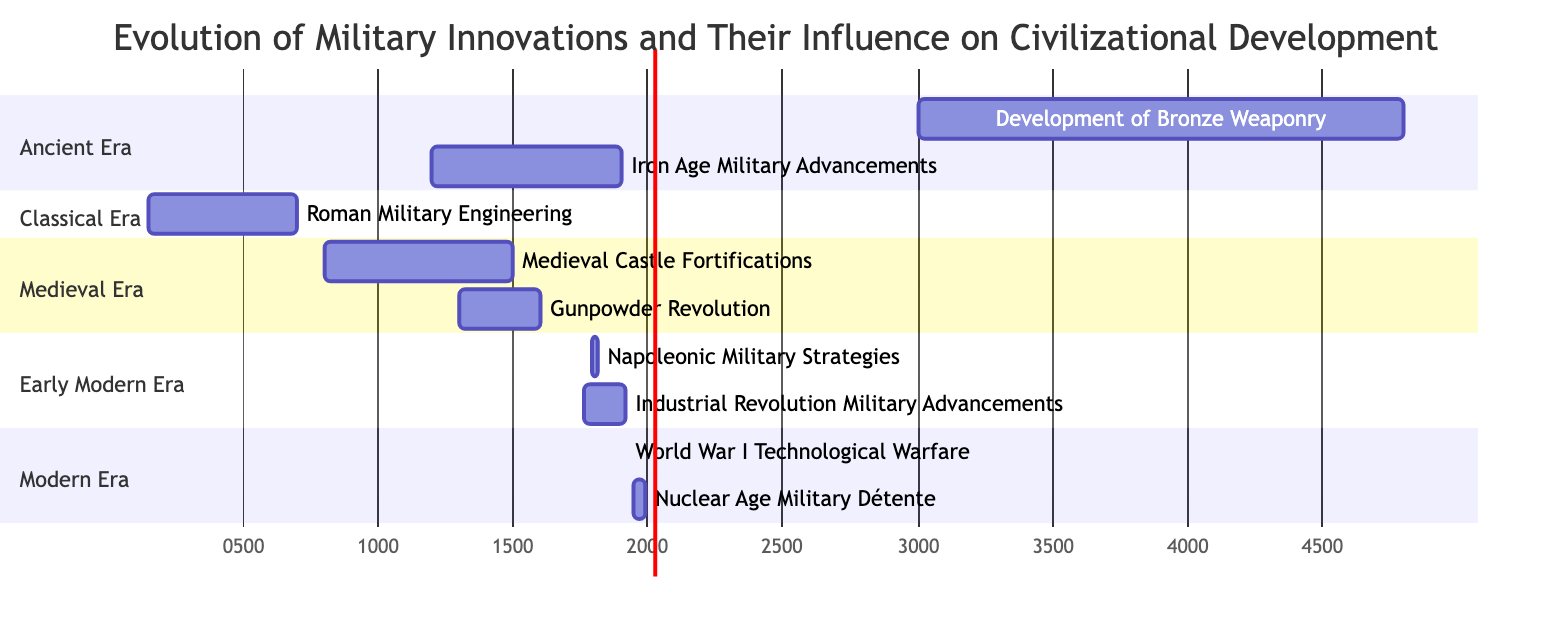What is the duration of the Gunpowder Revolution? The Gantt Chart shows that the Gunpowder Revolution starts in 1300 CE and ends in 1600 CE. To find the duration, subtract the start time from the end time: 1600 - 1300 = 300 years.
Answer: 300 years Which military innovation overlaps with the Medieval Castle Fortifications? By examining the timeline in the Gantt Chart, the Medieval Castle Fortifications begin in 800 CE and end in 1500 CE. Overlapping with it is the Gunpowder Revolution, which starts in 1300 CE and ends in 1600 CE. Thus, both innovations overlap in this period.
Answer: Gunpowder Revolution How many military innovations occurred in the Ancient Era? The Ancient Era includes two innovations according to the Gantt Chart: Development of Bronze Weaponry and Iron Age Military Advancements. Counting these innovations gives us a total of two.
Answer: 2 What time period does the Napoleonic Military Strategies cover? The Gantt Chart indicates that Napoleonic Military Strategies began in 1790 CE and ended in 1815 CE, making it a 25-year period.
Answer: 25 years Which military advancement started earliest? Looking at the start times of each innovation in the Gantt Chart, the earliest innovation is the Development of Bronze Weaponry, which begins at 3000 BCE.
Answer: Development of Bronze Weaponry What is the end year of the Industrial Revolution Military Advancements? The Gantt Chart highlights that the Industrial Revolution Military Advancements started in 1760 CE and ended in 1914 CE. Therefore, the end year for this innovation is 1914 CE.
Answer: 1914 CE Which two periods are represented in the section of the Modern Era? The Gantt Chart shows the Modern Era includes World War I Technological Warfare and Nuclear Age Military Détente. The question requires identifying these two entries from the given era.
Answer: World War I Technological Warfare and Nuclear Age Military Détente Which military innovation has the longest duration? By analyzing the durations of each military innovation on the Gantt Chart, the Industrial Revolution Military Advancements spans from 1760 CE to 1914 CE, totaling 154 years, which is the longest duration among them.
Answer: Industrial Revolution Military Advancements 